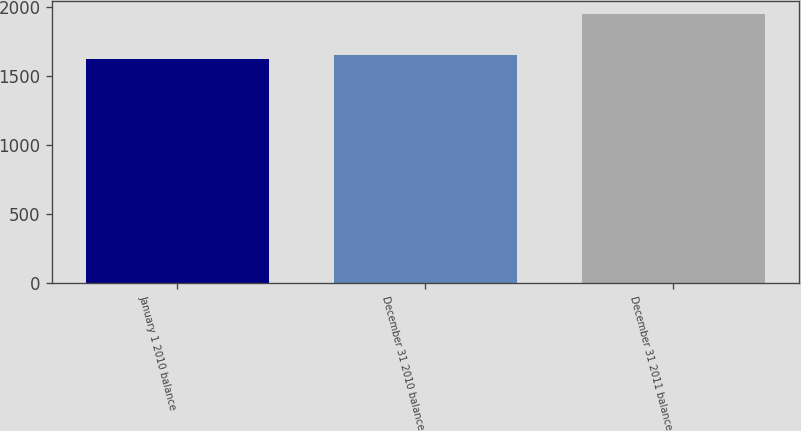Convert chart. <chart><loc_0><loc_0><loc_500><loc_500><bar_chart><fcel>January 1 2010 balance<fcel>December 31 2010 balance<fcel>December 31 2011 balance<nl><fcel>1619.9<fcel>1652.44<fcel>1945.3<nl></chart> 